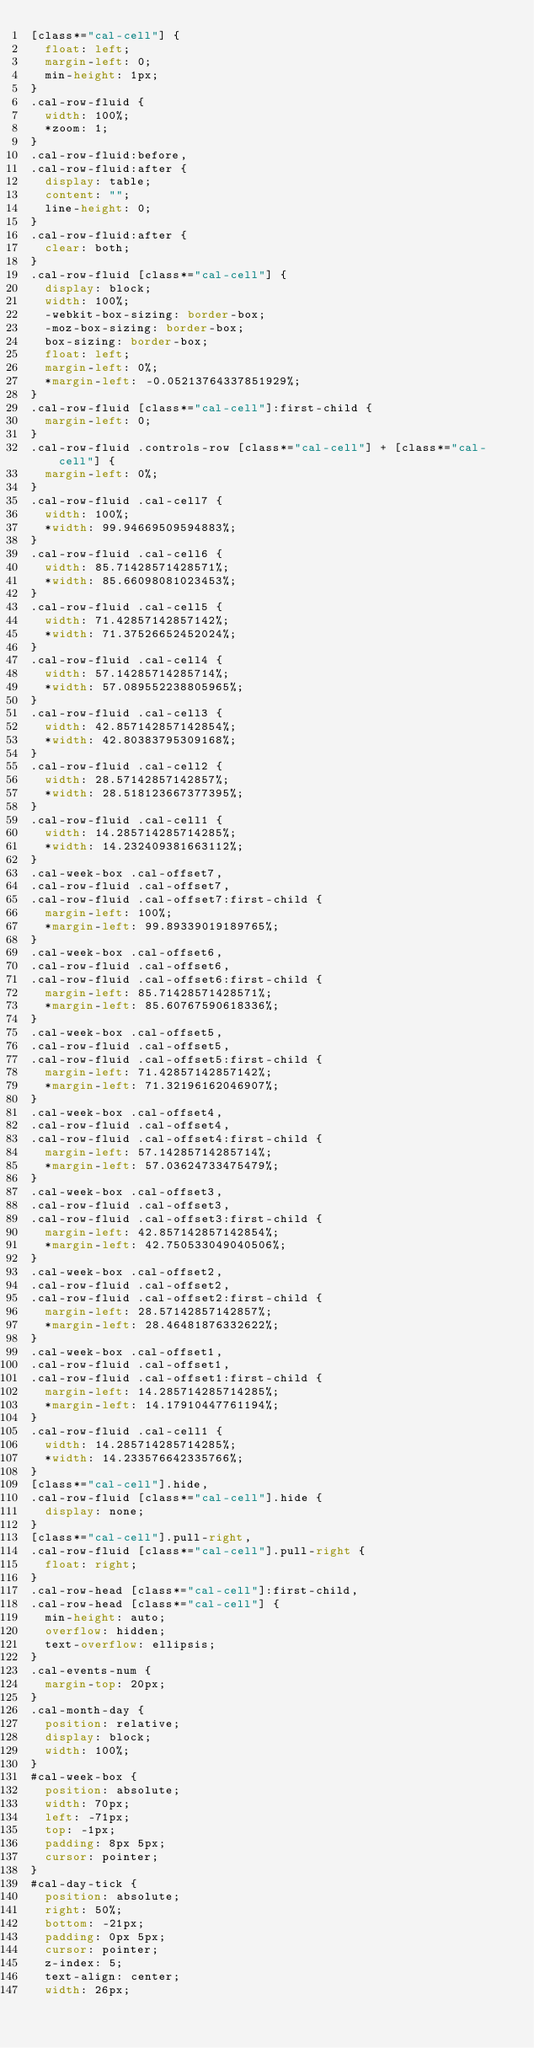<code> <loc_0><loc_0><loc_500><loc_500><_CSS_>[class*="cal-cell"] {
  float: left;
  margin-left: 0;
  min-height: 1px;
}
.cal-row-fluid {
  width: 100%;
  *zoom: 1;
}
.cal-row-fluid:before,
.cal-row-fluid:after {
  display: table;
  content: "";
  line-height: 0;
}
.cal-row-fluid:after {
  clear: both;
}
.cal-row-fluid [class*="cal-cell"] {
  display: block;
  width: 100%;
  -webkit-box-sizing: border-box;
  -moz-box-sizing: border-box;
  box-sizing: border-box;
  float: left;
  margin-left: 0%;
  *margin-left: -0.05213764337851929%;
}
.cal-row-fluid [class*="cal-cell"]:first-child {
  margin-left: 0;
}
.cal-row-fluid .controls-row [class*="cal-cell"] + [class*="cal-cell"] {
  margin-left: 0%;
}
.cal-row-fluid .cal-cell7 {
  width: 100%;
  *width: 99.94669509594883%;
}
.cal-row-fluid .cal-cell6 {
  width: 85.71428571428571%;
  *width: 85.66098081023453%;
}
.cal-row-fluid .cal-cell5 {
  width: 71.42857142857142%;
  *width: 71.37526652452024%;
}
.cal-row-fluid .cal-cell4 {
  width: 57.14285714285714%;
  *width: 57.089552238805965%;
}
.cal-row-fluid .cal-cell3 {
  width: 42.857142857142854%;
  *width: 42.80383795309168%;
}
.cal-row-fluid .cal-cell2 {
  width: 28.57142857142857%;
  *width: 28.518123667377395%;
}
.cal-row-fluid .cal-cell1 {
  width: 14.285714285714285%;
  *width: 14.232409381663112%;
}
.cal-week-box .cal-offset7,
.cal-row-fluid .cal-offset7,
.cal-row-fluid .cal-offset7:first-child {
  margin-left: 100%;
  *margin-left: 99.89339019189765%;
}
.cal-week-box .cal-offset6,
.cal-row-fluid .cal-offset6,
.cal-row-fluid .cal-offset6:first-child {
  margin-left: 85.71428571428571%;
  *margin-left: 85.60767590618336%;
}
.cal-week-box .cal-offset5,
.cal-row-fluid .cal-offset5,
.cal-row-fluid .cal-offset5:first-child {
  margin-left: 71.42857142857142%;
  *margin-left: 71.32196162046907%;
}
.cal-week-box .cal-offset4,
.cal-row-fluid .cal-offset4,
.cal-row-fluid .cal-offset4:first-child {
  margin-left: 57.14285714285714%;
  *margin-left: 57.03624733475479%;
}
.cal-week-box .cal-offset3,
.cal-row-fluid .cal-offset3,
.cal-row-fluid .cal-offset3:first-child {
  margin-left: 42.857142857142854%;
  *margin-left: 42.750533049040506%;
}
.cal-week-box .cal-offset2,
.cal-row-fluid .cal-offset2,
.cal-row-fluid .cal-offset2:first-child {
  margin-left: 28.57142857142857%;
  *margin-left: 28.46481876332622%;
}
.cal-week-box .cal-offset1,
.cal-row-fluid .cal-offset1,
.cal-row-fluid .cal-offset1:first-child {
  margin-left: 14.285714285714285%;
  *margin-left: 14.17910447761194%;
}
.cal-row-fluid .cal-cell1 {
  width: 14.285714285714285%;
  *width: 14.233576642335766%;
}
[class*="cal-cell"].hide,
.cal-row-fluid [class*="cal-cell"].hide {
  display: none;
}
[class*="cal-cell"].pull-right,
.cal-row-fluid [class*="cal-cell"].pull-right {
  float: right;
}
.cal-row-head [class*="cal-cell"]:first-child,
.cal-row-head [class*="cal-cell"] {
  min-height: auto;
  overflow: hidden;
  text-overflow: ellipsis;
}
.cal-events-num {
  margin-top: 20px;
}
.cal-month-day {
  position: relative;
  display: block;
  width: 100%;
}
#cal-week-box {
  position: absolute;
  width: 70px;
  left: -71px;
  top: -1px;
  padding: 8px 5px;
  cursor: pointer;
}
#cal-day-tick {
  position: absolute;
  right: 50%;
  bottom: -21px;
  padding: 0px 5px;
  cursor: pointer;
  z-index: 5;
  text-align: center;
  width: 26px;</code> 